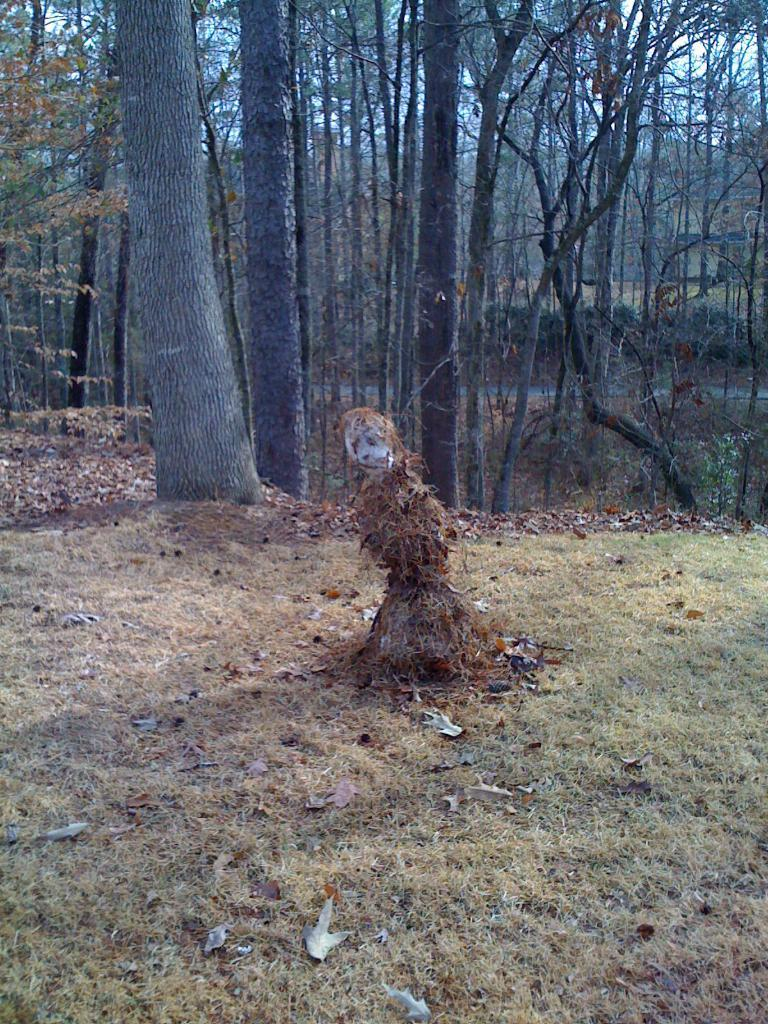What type of surface is visible on the ground in the image? There is grass on the ground in the image. What can be seen in the middle of the image? There is a scary toy in the middle of the image. What type of vegetation is visible at the top of the image? There are trees at the top of the image. How many noses can be seen on the scary toy in the image? There are no noses visible on the scary toy in the image, as it is a toy and not a living being. Are there any cobwebs present in the image? There is no mention of cobwebs in the provided facts, and therefore we cannot determine if any are present in the image. 